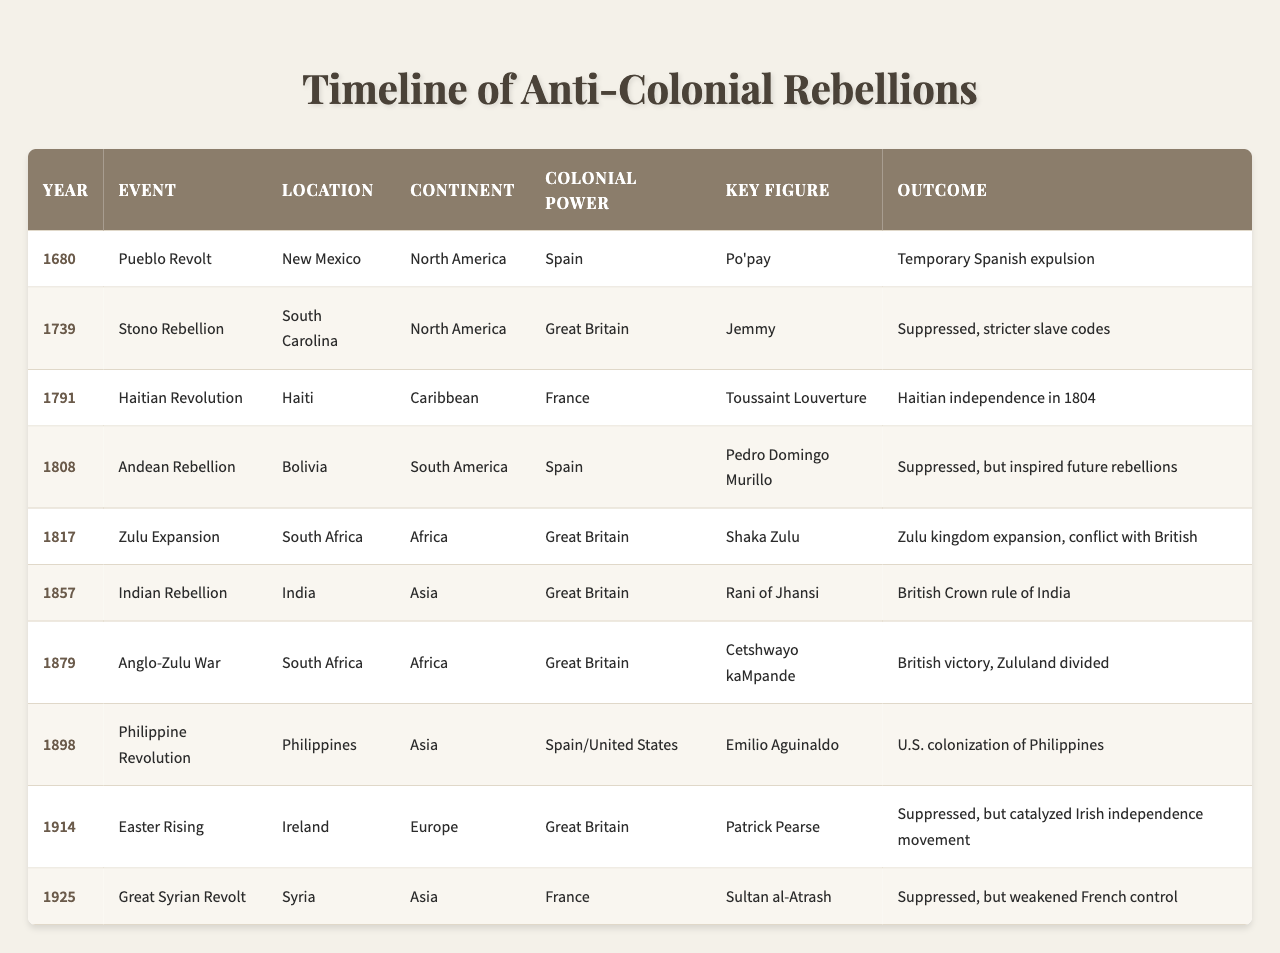What year did the Haitian Revolution occur? The table lists the Haitian Revolution under the "Event" column, and the corresponding "Year" is provided in the same row. From the table, the year is identified as 1791.
Answer: 1791 Who was the key figure in the Indian Rebellion of 1857? The table specifies the key figure associated with the Indian Rebellion in the "Key Figure" column. For the year 1857, the name listed is Rani of Jhansi.
Answer: Rani of Jhansi How many anti-colonial rebellions occurred in the 19th century? By reviewing the "Year" column, the rebellions that occurred between 1800 and 1899 are counted: Haitian Revolution (1791), Indian Rebellion (1857), Anglo-Zulu War (1879), and the Philippine Revolution (1898). There are four that fit within the 19th century timeframe.
Answer: 4 Which rebellion had the outcome of inspiring future rebellions? The outcome of the "Andean Rebellion" in Bolivia is described in the "Outcome" column, which states "Suppressed, but inspired future rebellions." Thus, we identify this event as having that specific outcome.
Answer: Andean Rebellion What is the relationship between the Zulu Expansion and British colonial power? The Zulu Expansion in South Africa, led by Shaka Zulu, occurred under British colonial power, as indicated in their respective columns. The aftermath was significant as it led to Zulu kingdom expansion and conflict with the British.
Answer: The Zulu Expansion led to conflict with British colonial power How many events occurred in Africa compared to South America? The table shows the events listed in "Continent" for Africa: (Zulu Expansion, Anglo-Zulu War), making it 2 events. For South America, there is only the Andean Rebellion. Therefore, there are more events in Africa than in South America by a count of 1.
Answer: Africa: 2, South America: 1 Was the Easter Rising successful in achieving its initial goals? The table states under "Outcome" for the Easter Rising that it was "Suppressed, but catalyzed Irish independence movement." Given this information, it did not succeed in its immediate goals but did contribute to later objectives.
Answer: No Identify the colonial powers involved in the South Carolina Stono Rebellion. Referring to the "Colonial Power" column, it is specified that the Stono Rebellion in South Carolina was under Great Britain's control. Hence, the answer is Great Britain.
Answer: Great Britain What rebellion took place in the year nearest to 1800? By checking the "Year" column, the events close to 1800 are the "Haitian Revolution" in 1791 and the "Andean Rebellion" in 1808. Therefore, the "Andean Rebellion" at 1808 occurs nearest to 1800.
Answer: Andean Rebellion Which anti-colonial uprising had the longest-lasting outcome? Reviewing the various outcomes listed, the Haitian Revolution culminated in Haitian independence in 1804, suggesting a significant and lasting impact compared to others which were more temporary in nature, such as the Pueblo Revolt.
Answer: Haitian Revolution How many different continents were involved in the rebellions? Each entry in the "Continent" column is unique and can be counted. The continents represent North America, Caribbean, South America, Africa, Asia, and Europe, totaling to six different continents involved in the rebellions.
Answer: 6 